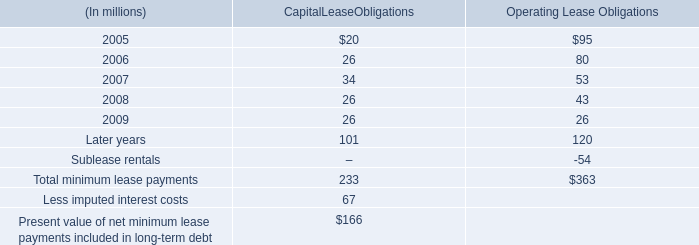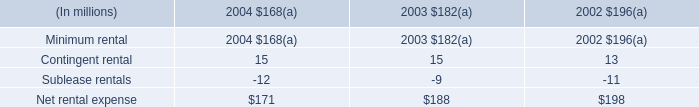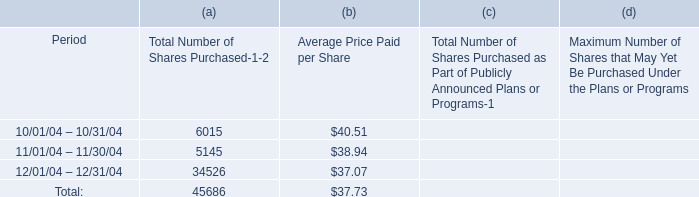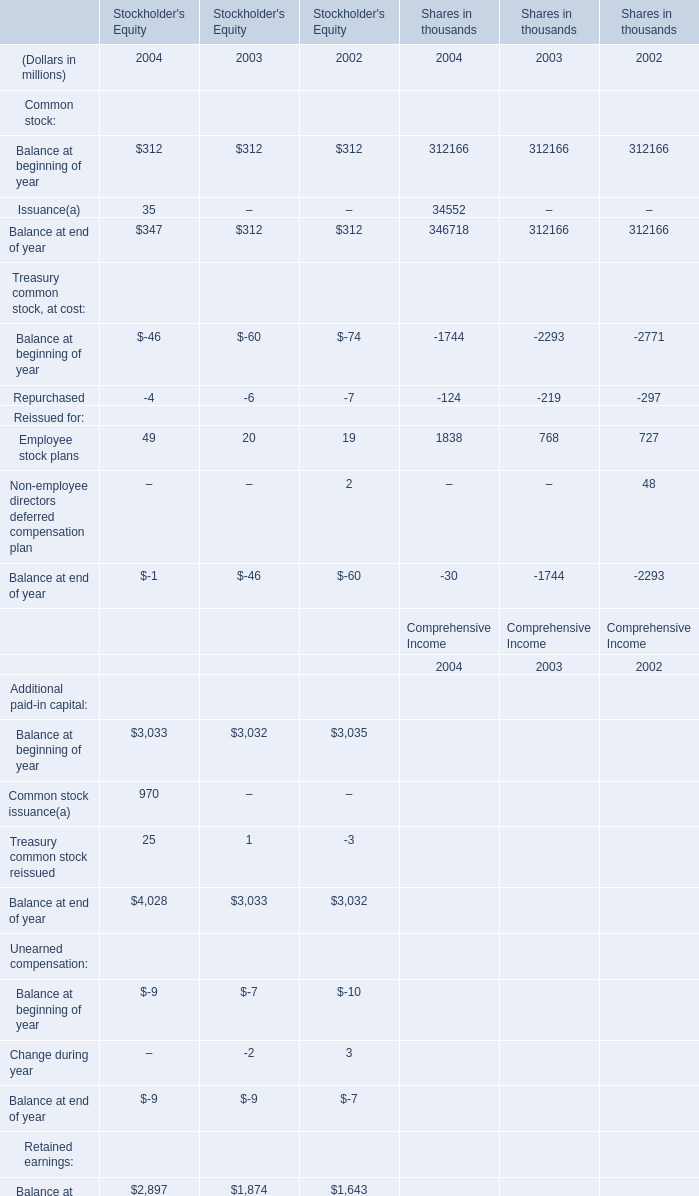for the periods 10/01/04 2013 10/31/04 and 11/01/04 2013 11/30/04 what were the average price paid per share? 
Computations: ((40.51 + 38.94) / 2)
Answer: 39.725. 